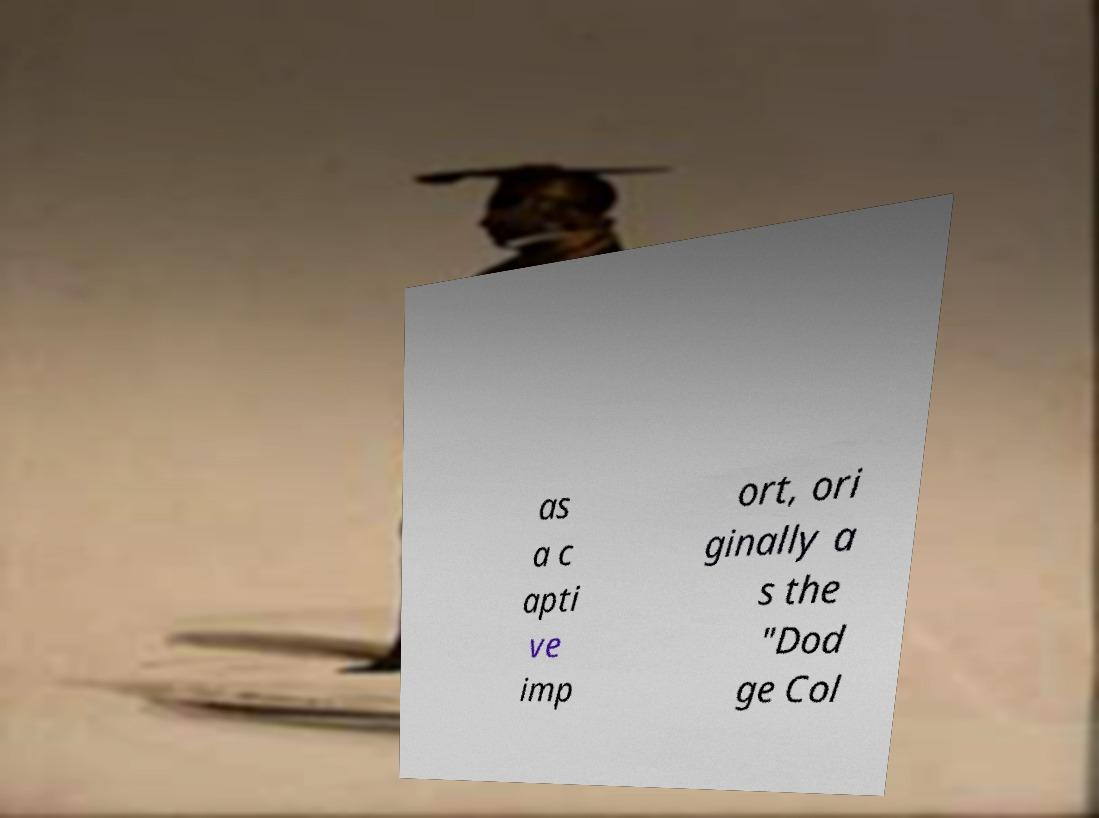Can you read and provide the text displayed in the image?This photo seems to have some interesting text. Can you extract and type it out for me? as a c apti ve imp ort, ori ginally a s the "Dod ge Col 